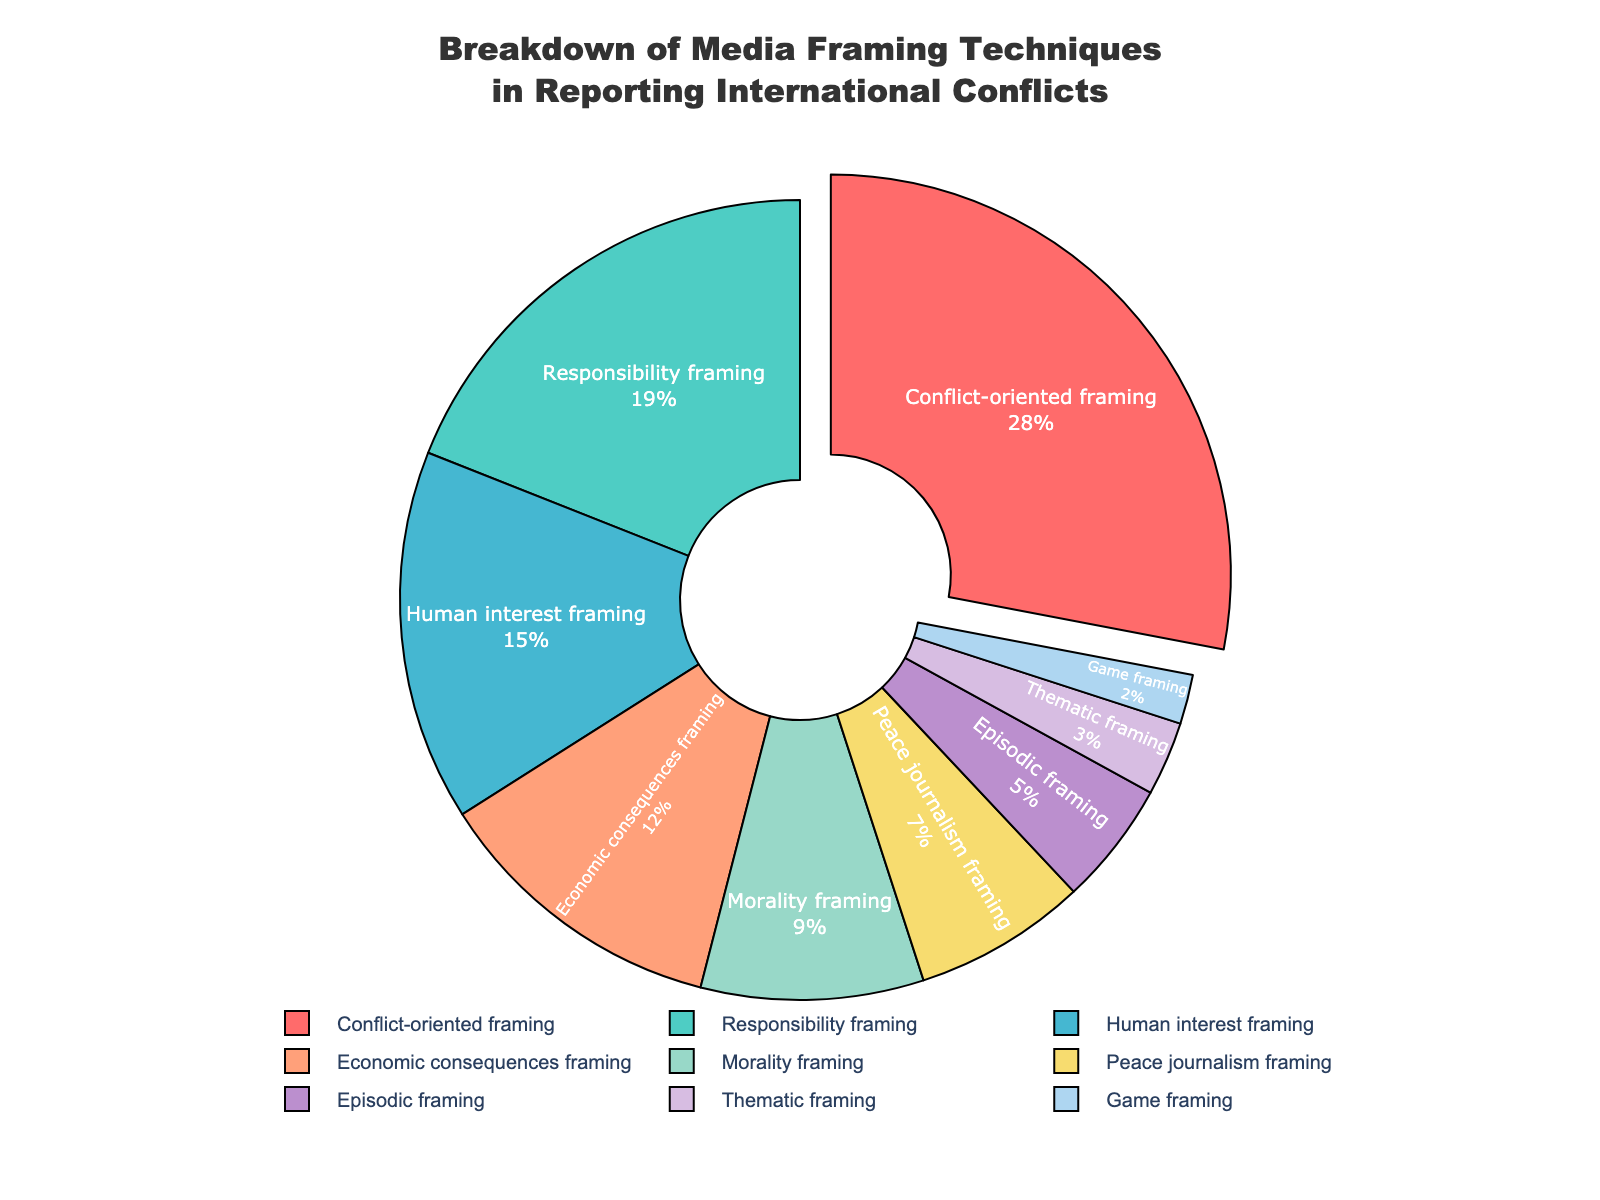Which framing technique is used the most in reporting international conflicts? To determine which framing technique is used the most, check the data or the largest segment of the pie chart. The segment labeled "Conflict-oriented framing" has the largest proportion at 28%.
Answer: Conflict-oriented framing Which framing technique has the smallest percentage in the chart? To identify the framing technique with the smallest percentage, look for the smallest segment in the pie chart. The "Game framing" segment is the smallest, with 2%.
Answer: Game framing What is the combined percentage of "Human interest framing" and "Economic consequences framing"? Sum the percentages of the "Human interest framing" (15%) and "Economic consequences framing" (12%). 15% + 12% = 27%.
Answer: 27% Which two framing techniques together account for more than 35% of the media coverage? First, identify the two largest segments from the pie chart. "Conflict-oriented framing" (28%) and "Responsibility framing" (19%) combined account for 28% + 19% = 47%, which is more than 35%.
Answer: Conflict-oriented framing, Responsibility framing What is the difference in percentages between "Morality framing" and "Peace journalism framing"? Subtract the percentage of "Peace journalism framing" (7%) from the percentage of "Morality framing" (9%). 9% - 7% = 2%.
Answer: 2% How does the percentage of "Thematic framing" compare to the percentage of "Episodic framing"? Compare the percentages directly. "Thematic framing" has 3%, while "Episodic framing" has 5%. Thus, "Thematic framing" has a smaller percentage than "Episodic framing".
Answer: Thematic framing is less than Episodic framing If you group "Peace journalism framing", "Episodic framing", "Thematic framing", and "Game framing" together, what percentage do they represent collectively? Sum the percentages of "Peace journalism framing" (7%), "Episodic framing" (5%), "Thematic framing" (3%), and "Game framing" (2%). 7% + 5% + 3% + 2% = 17%.
Answer: 17% Which framing technique is represented by the color red in the pie chart? By referring to the color legend provided, the red color segment represents the "Conflict-oriented framing".
Answer: Conflict-oriented framing Are there more framing techniques with percentages above or below 10%? Count the number of framing techniques with percentages above and below 10%. Above 10%: Conflict-oriented framing (28%), Responsibility framing (19%), Human interest framing (15%), Economic consequences framing (12%). Total = 4. Below 10%: Morality framing (9%), Peace journalism framing (7%), Episodic framing (5%), Thematic framing (3%), Game framing (2%). Total = 5.
Answer: Below 10% What framing technique is the closest in percentage to "Economic consequences framing"? Compare the percentages of the framing techniques. "Human interest framing" is 3 percentage points different from "Economic consequences framing" (12%) with a percentage of 15%.
Answer: Human interest framing 